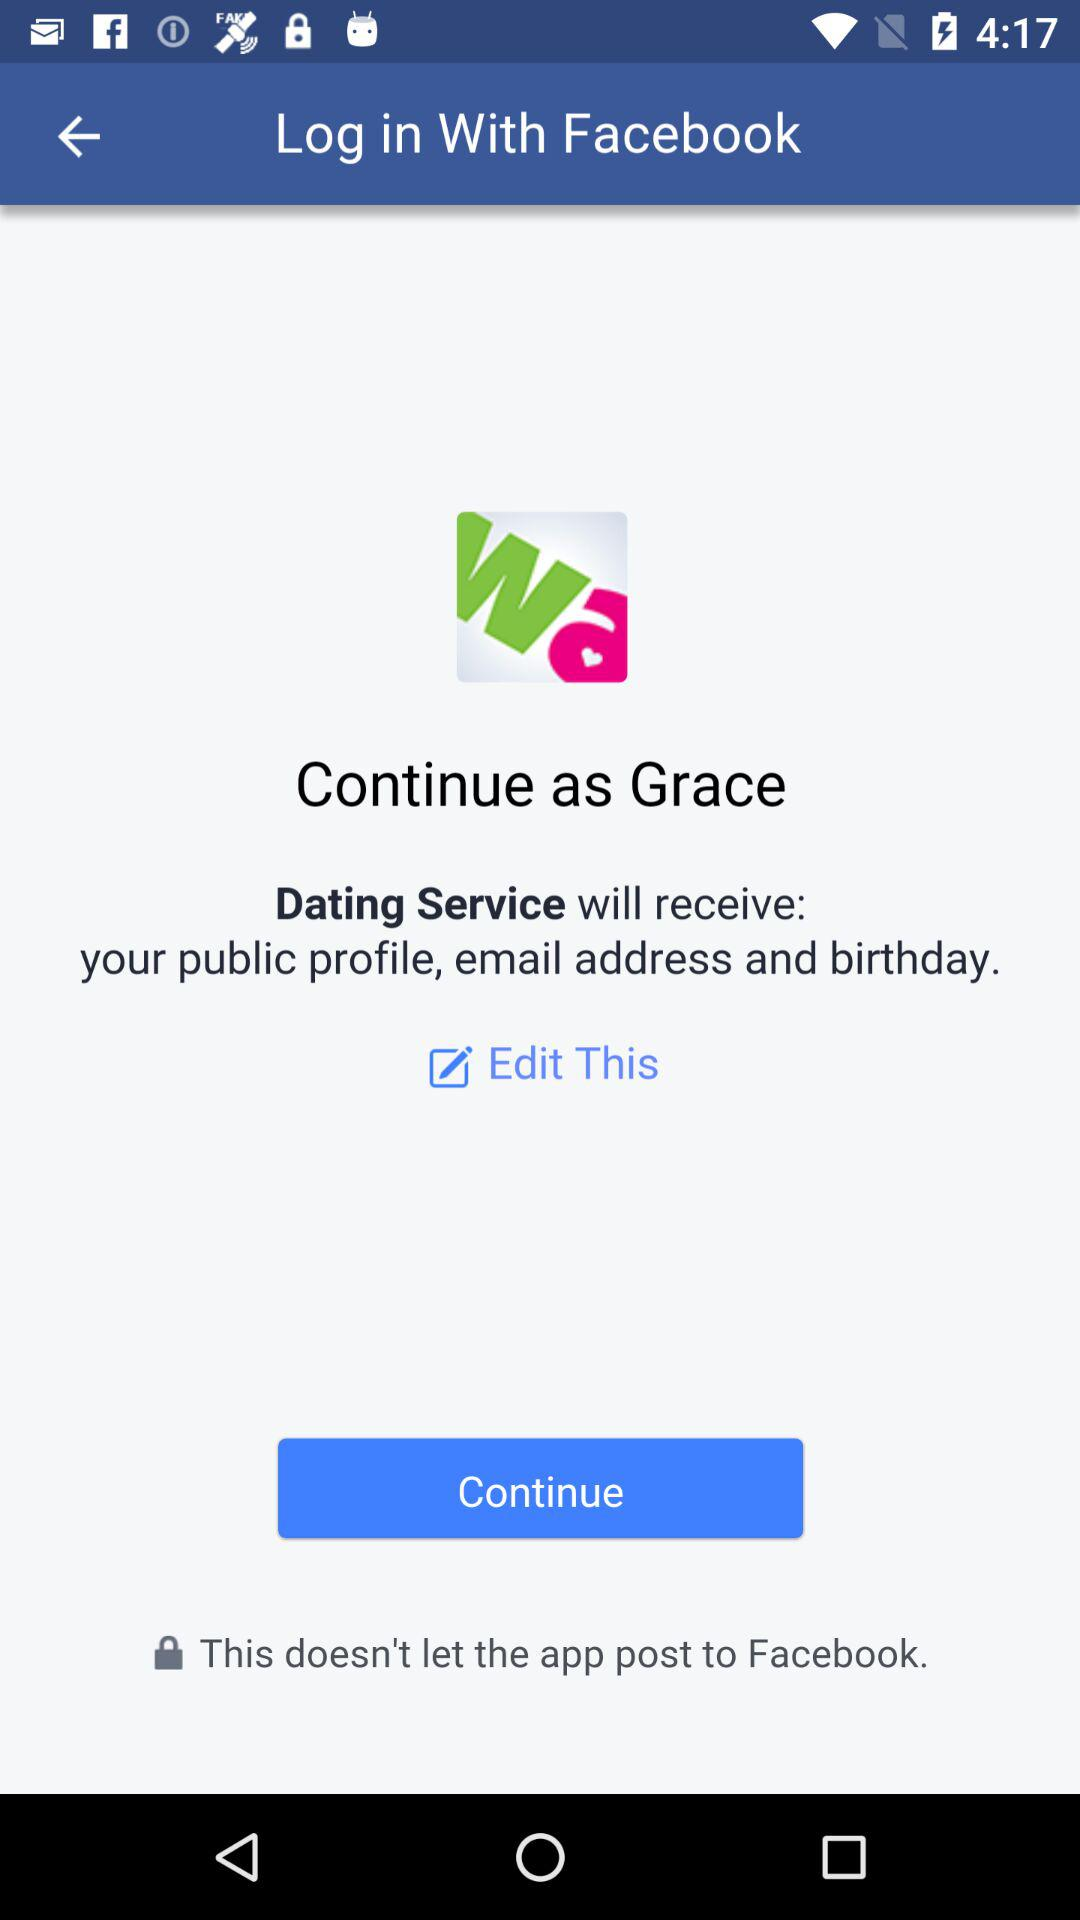What is the user name? The user name is Grace. 